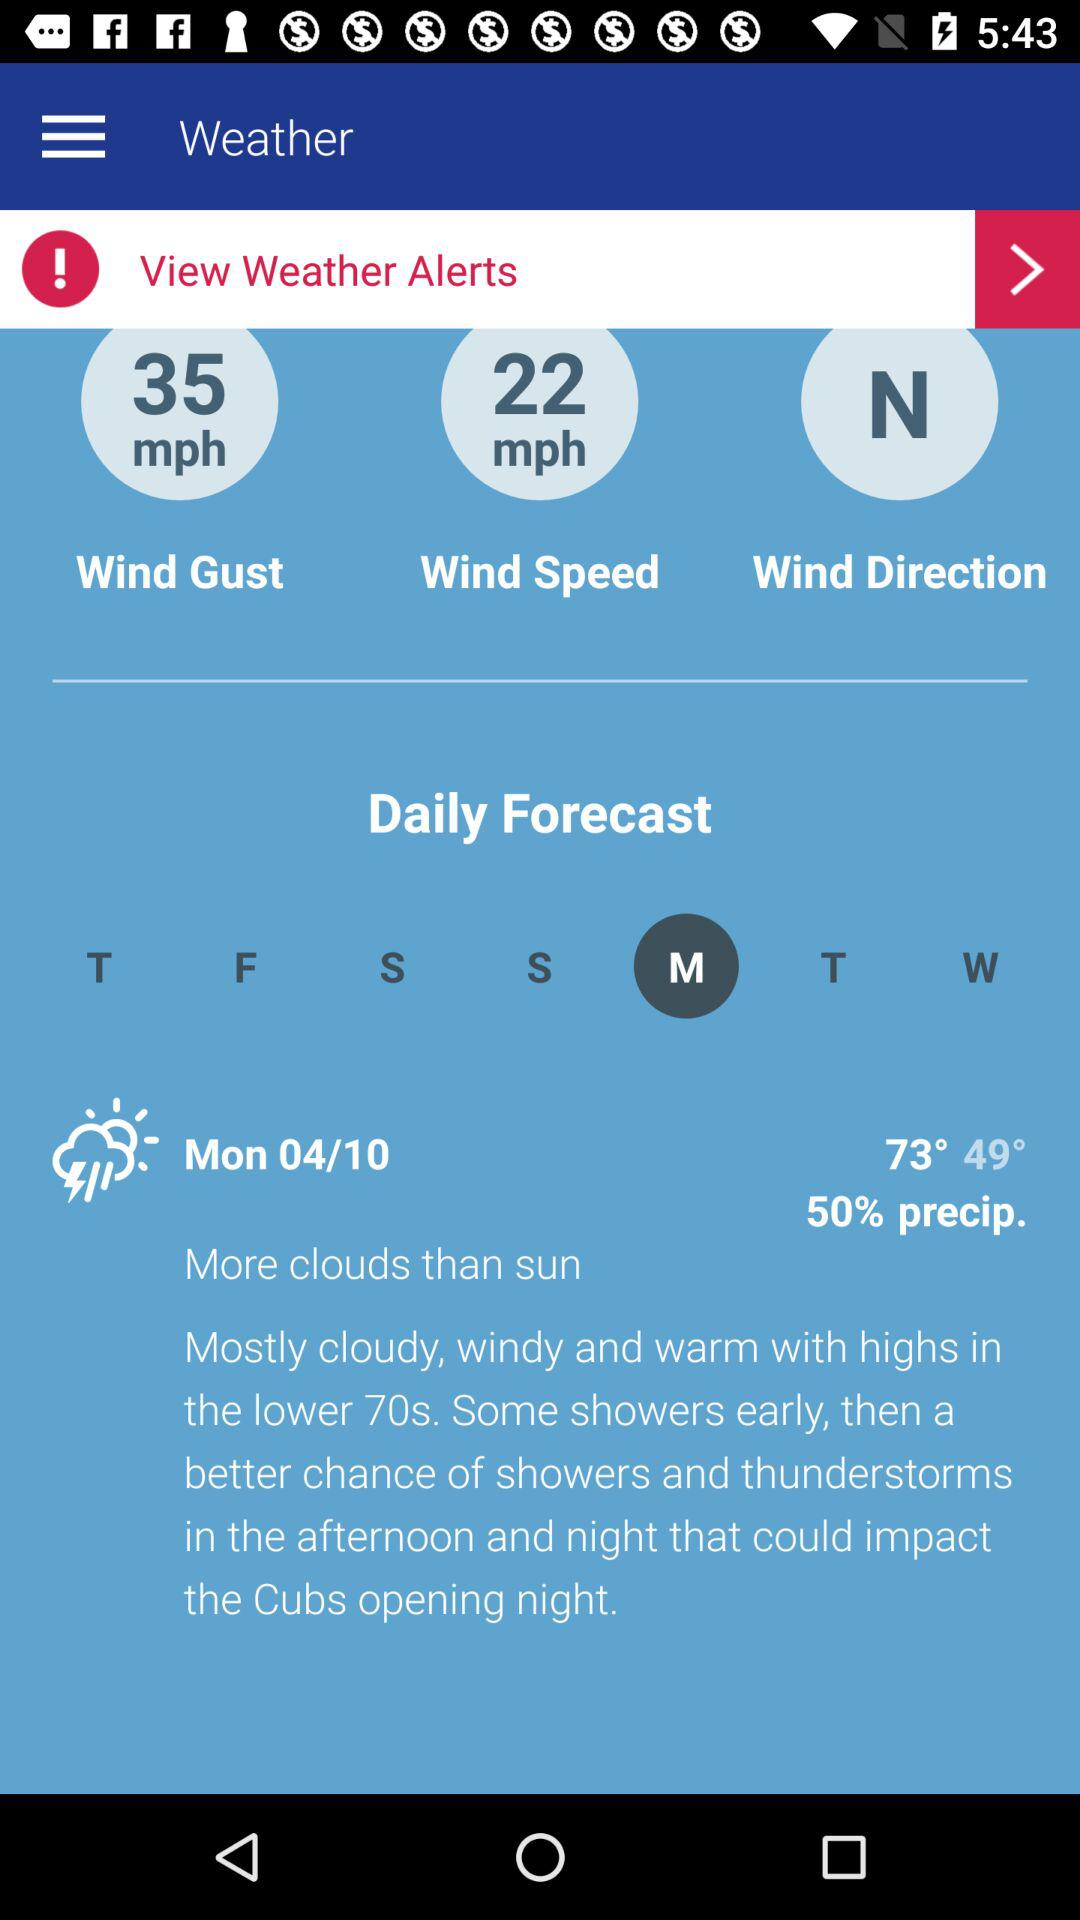What is the wind speed for today?
Answer the question using a single word or phrase. 22 mph 